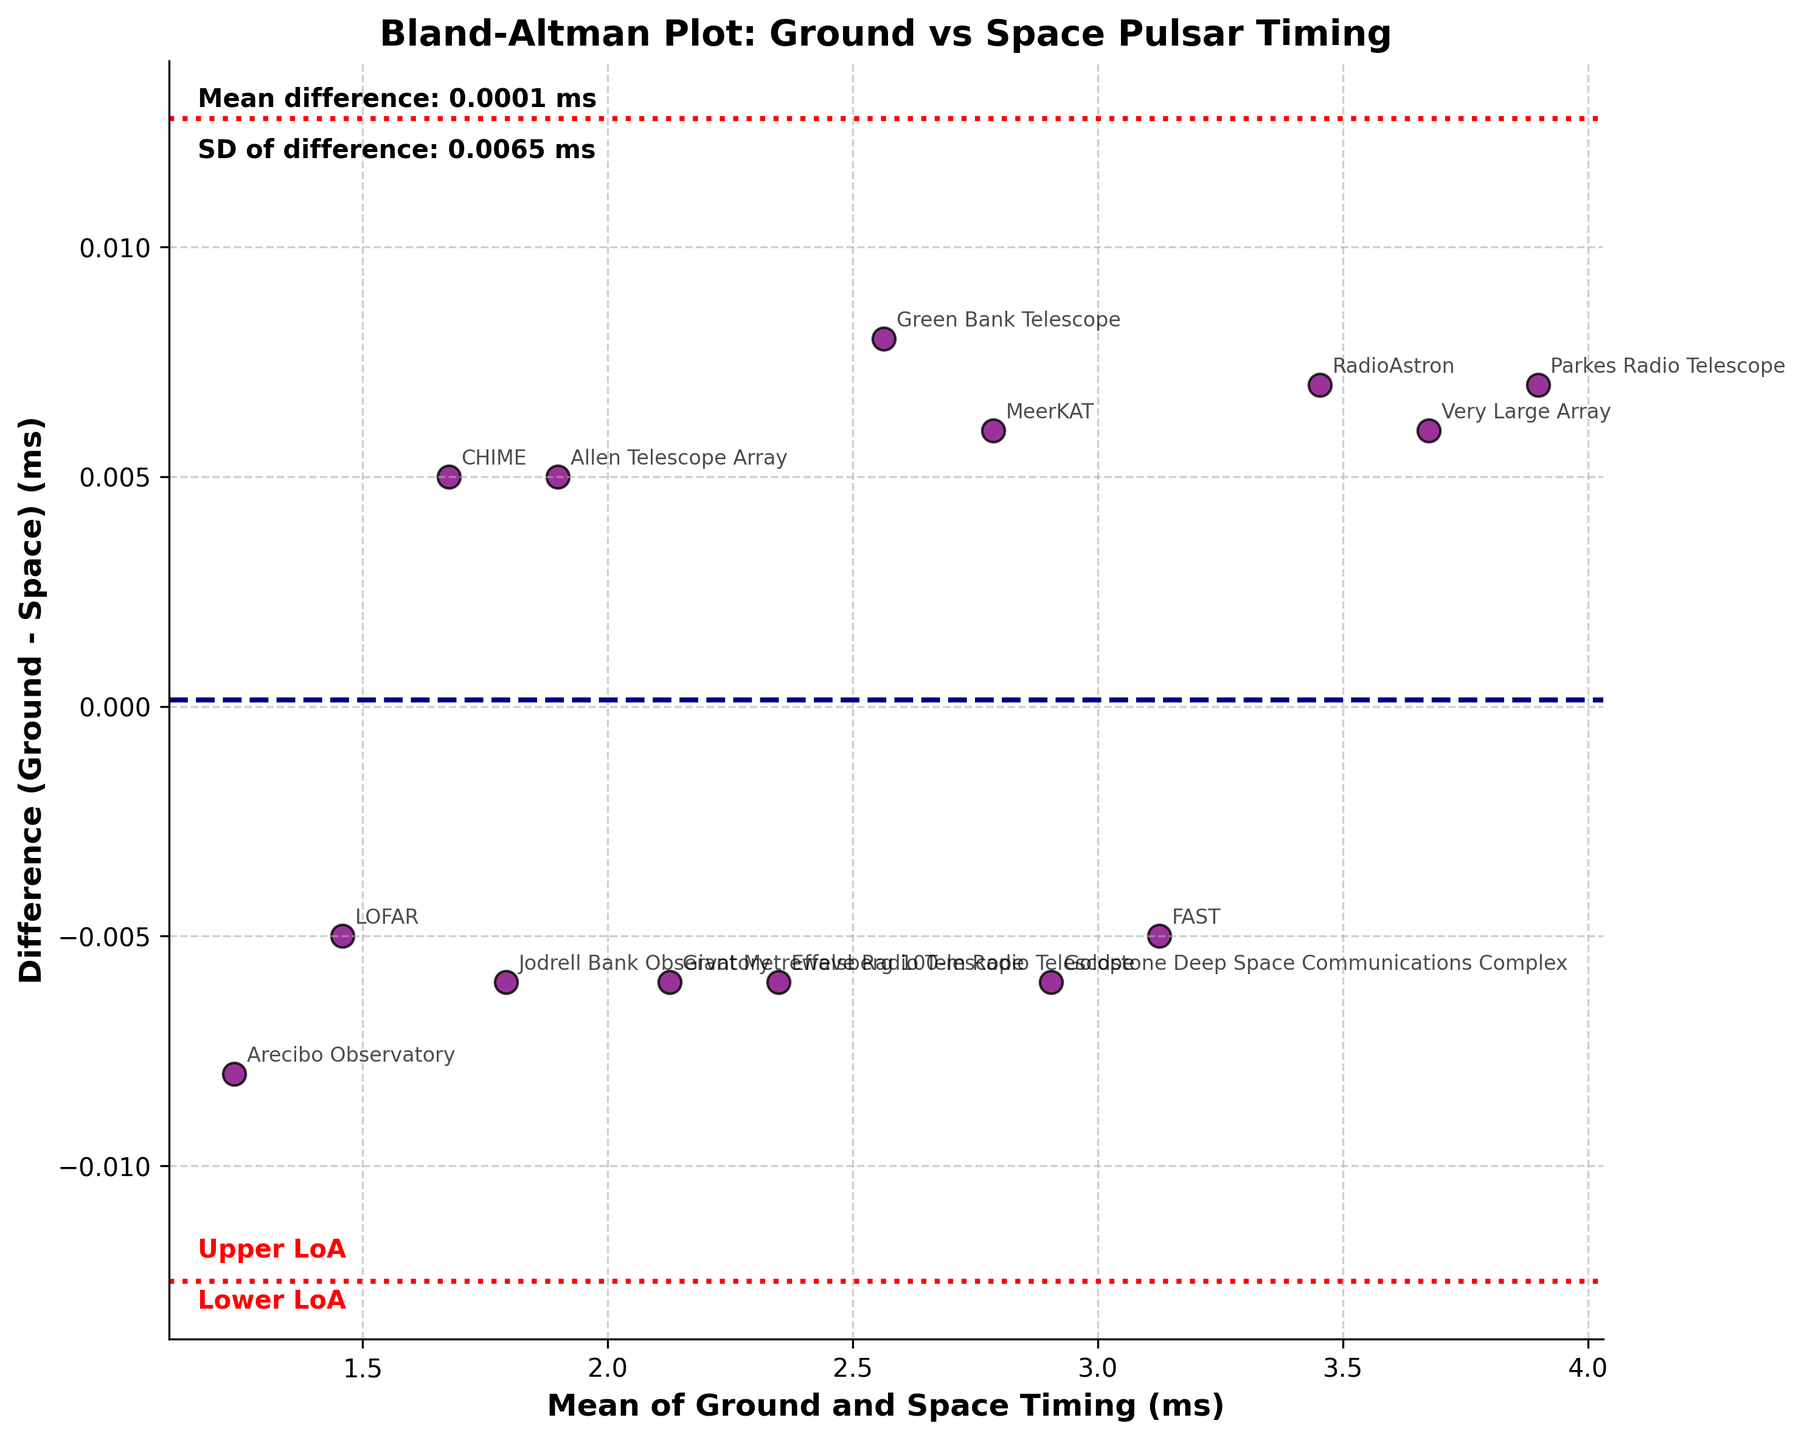What's the title of the plot? The title of the plot is located at the top and usually describes the content or purpose of the figure. In this plot, it reads "Bland-Altman Plot: Ground vs Space Pulsar Timing".
Answer: Bland-Altman Plot: Ground vs Space Pulsar Timing How many data points are plotted in the figure? Each point on the plot represents one observatory. By counting the observatories listed in the data, there are 14 data points.
Answer: 14 Which observatory has the highest difference between ground and space timing? To find the largest difference, observe the vertical position of the points. The point with the highest vertical value represents the largest positive difference. Jodrell Bank Observatory has the highest difference.
Answer: Jodrell Bank Observatory What is the horizontal axis labeled as, and what does it represent? The horizontal axis is labeled as "Mean of Ground and Space Timing (ms)," representing the average of the ground and space timing measurements for each observatory.
Answer: Mean of Ground and Space Timing (ms) What are the mean and standard deviation (SD) of the differences, and where are these indicated on the plot? The mean difference is indicated by a dashed line, and the SD is mentioned in the figure's annotations. From the figure, the mean difference is around -0.0023 ms and the SD is around 0.0045 ms.
Answer: Mean difference: -0.0023 ms, SD: 0.0045 ms What are the Limits of Agreement (LoA) in this plot? The Limits of Agreement are calculated as the mean difference ± 1.96 * SD and are represented by red dotted lines. From the figure, the lower LoA is approximately -0.0109 ms, and the upper LoA is around 0.0063 ms.
Answer: Lower LoA: -0.0109 ms, Upper LoA: 0.0063 ms Which observatory is the closest to having no difference between ground and space timing? The observatory closest to having no difference has a point closest to the horizontal line at y=0. The Allen Telescope Array is almost at this line, indicating negligible difference.
Answer: Allen Telescope Array List the observatories that fall outside the Limits of Agreement. Observatories falling outside the Limits of Agreement have points outside the red dotted lines. From the plot, no observatories appear to fall outside the Limits of Agreement.
Answer: None What is the relationship between mean timing and difference in ground and space timing for the Very Large Array? The plot shows the point for the Very Large Array, located by its label. Its mean timing is around 3.675 ms, and the difference is slightly positive.
Answer: Mean: 3.675 ms, Difference: ~0.006 ms 